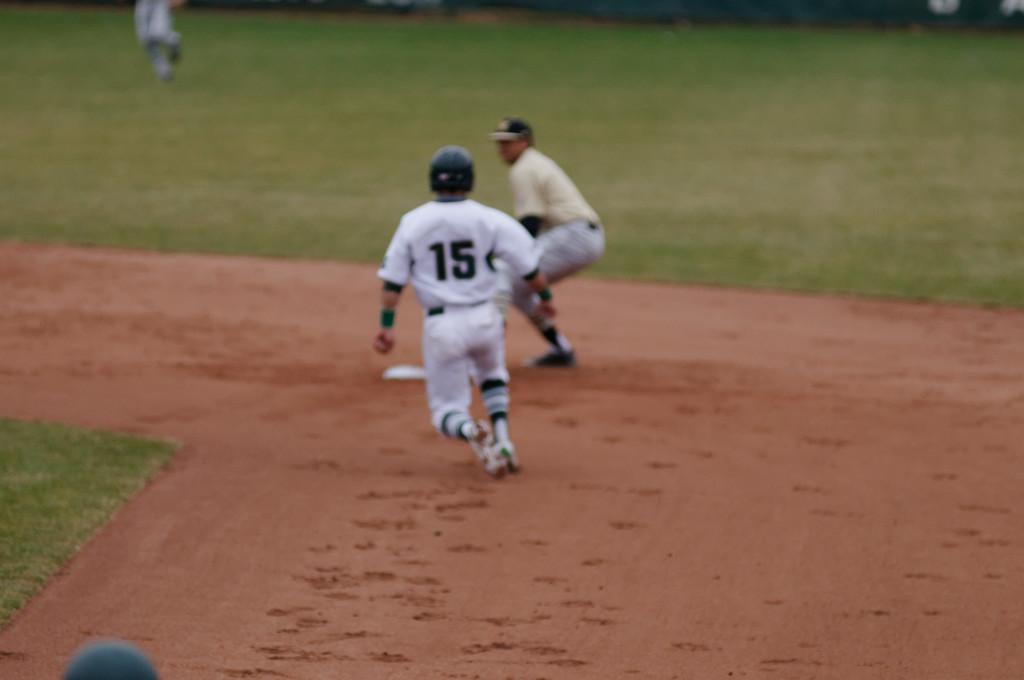What is the player's number?
Make the answer very short. 15. 